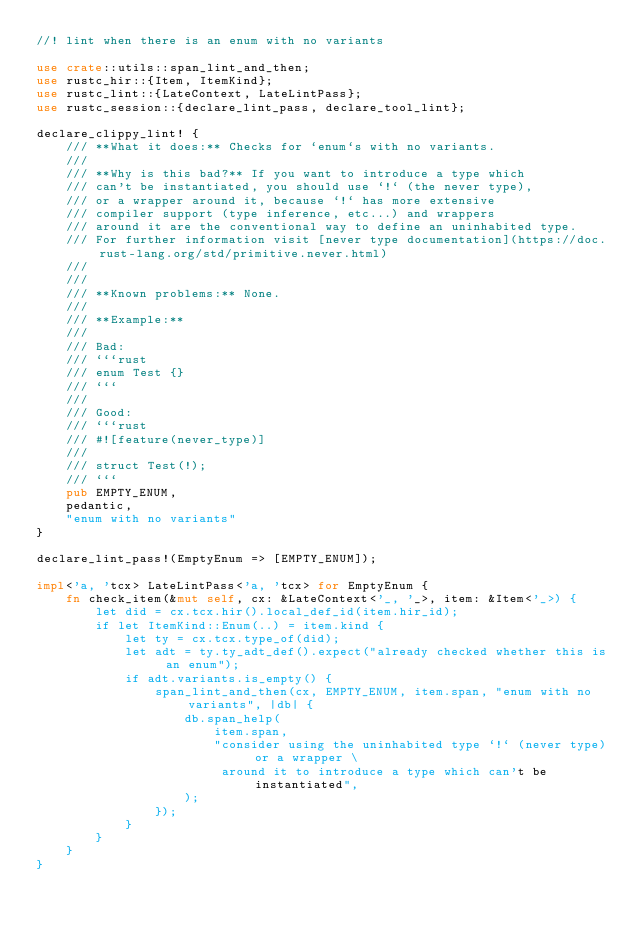Convert code to text. <code><loc_0><loc_0><loc_500><loc_500><_Rust_>//! lint when there is an enum with no variants

use crate::utils::span_lint_and_then;
use rustc_hir::{Item, ItemKind};
use rustc_lint::{LateContext, LateLintPass};
use rustc_session::{declare_lint_pass, declare_tool_lint};

declare_clippy_lint! {
    /// **What it does:** Checks for `enum`s with no variants.
    ///
    /// **Why is this bad?** If you want to introduce a type which
    /// can't be instantiated, you should use `!` (the never type),
    /// or a wrapper around it, because `!` has more extensive
    /// compiler support (type inference, etc...) and wrappers
    /// around it are the conventional way to define an uninhabited type.
    /// For further information visit [never type documentation](https://doc.rust-lang.org/std/primitive.never.html)
    ///
    ///
    /// **Known problems:** None.
    ///
    /// **Example:**
    ///
    /// Bad:
    /// ```rust
    /// enum Test {}
    /// ```
    ///
    /// Good:
    /// ```rust
    /// #![feature(never_type)]
    ///
    /// struct Test(!);
    /// ```
    pub EMPTY_ENUM,
    pedantic,
    "enum with no variants"
}

declare_lint_pass!(EmptyEnum => [EMPTY_ENUM]);

impl<'a, 'tcx> LateLintPass<'a, 'tcx> for EmptyEnum {
    fn check_item(&mut self, cx: &LateContext<'_, '_>, item: &Item<'_>) {
        let did = cx.tcx.hir().local_def_id(item.hir_id);
        if let ItemKind::Enum(..) = item.kind {
            let ty = cx.tcx.type_of(did);
            let adt = ty.ty_adt_def().expect("already checked whether this is an enum");
            if adt.variants.is_empty() {
                span_lint_and_then(cx, EMPTY_ENUM, item.span, "enum with no variants", |db| {
                    db.span_help(
                        item.span,
                        "consider using the uninhabited type `!` (never type) or a wrapper \
                         around it to introduce a type which can't be instantiated",
                    );
                });
            }
        }
    }
}
</code> 